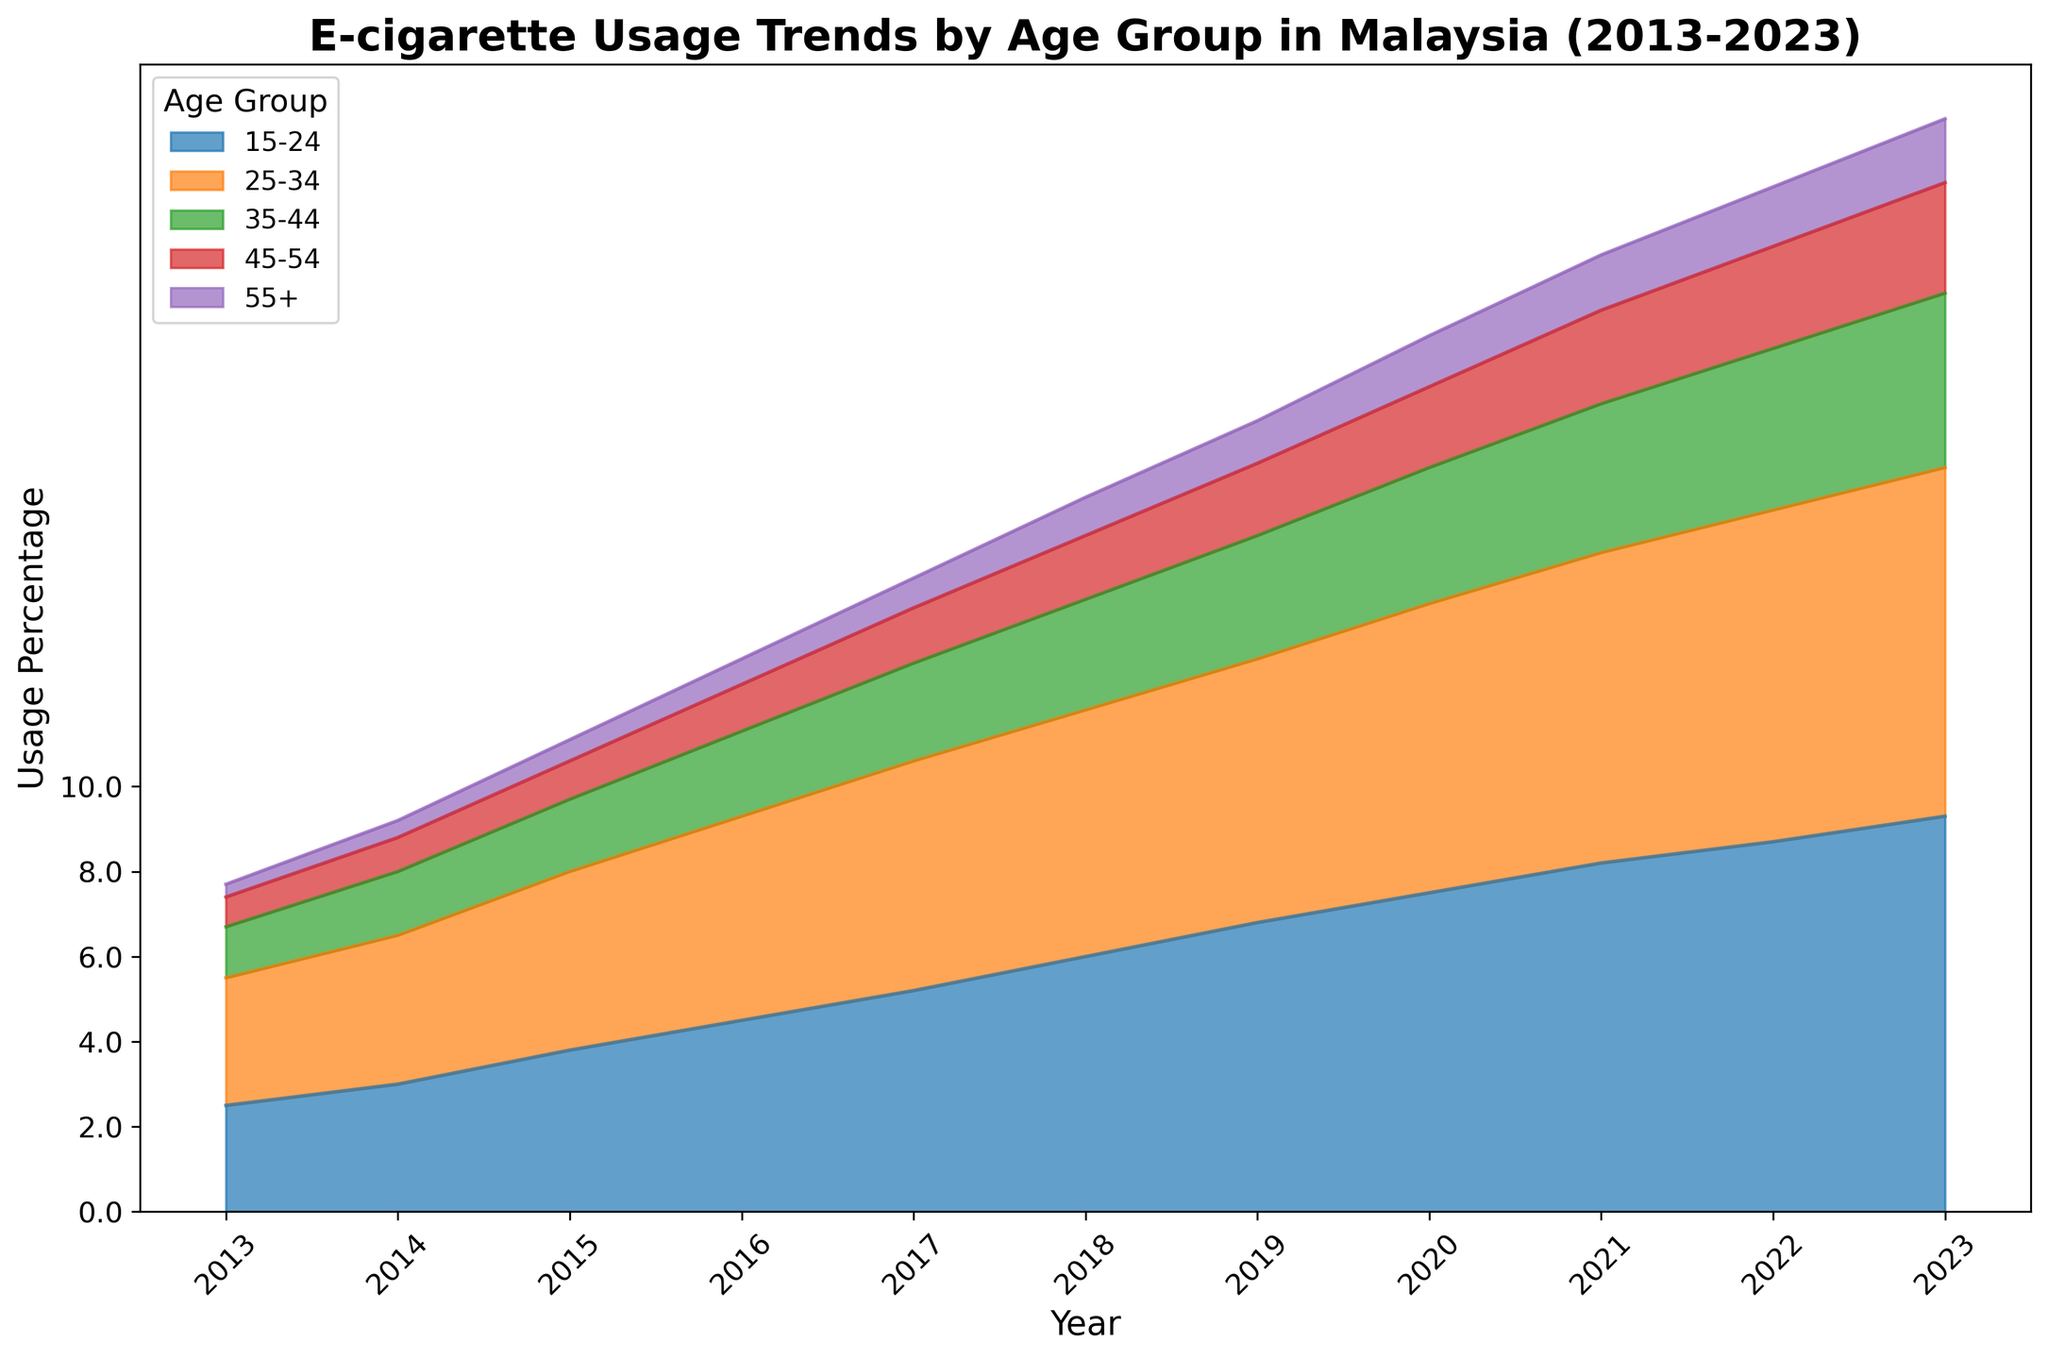What age group shows the highest e-cigarette usage in 2023? Look for the age group with the largest area towards the top of the plot in the year 2023, which is colored distinctly and has the highest percentage among all groups in that year.
Answer: 15-24 How did the e-cigarette usage percentage for the 25-34 age group change from 2013 to 2023? Identify the values for the 25-34 age group at the starting point (2013) and the ending point (2023). Then, subtract the 2013 value from the 2023 value to get the change.
Answer: Increase by 5.2% Which two age groups had an increase in their e-cigarette usage every year from 2013 to 2023? Observe the trend lines for each age group across the years. Look for continuous upward trends without any decline years.
Answer: 15-24 and 25-34 In which year did the total e-cigarette usage percentage across all age groups first exceed 10%? Sum the usage percentages for each age group for every year sequentially until the total exceeds 10%.
Answer: 2015 What was the range of e-cigarette usage percentages for the 35-44 age group from 2013 to 2023? Identify the minimum and maximum usage percentages for the 35-44 age group within the given years and subtract the minimum value from the maximum value to find the range.
Answer: 4.1% - 1.2% = 2.9% Between 2018 and 2023, which age group showed the smallest increase in e-cigarette usage? Calculate the difference in usage percentages for each age group from 2018 to 2023 and identify the group with the smallest increase.
Answer: 55+ Did the 45-54 age group ever have a higher e-cigarette usage percentage than the 35-44 age group? Compare the usage percentages for the 45-54 and 35-44 age groups across each year. Look for any year where the 45-54 percentage is higher than the 35-44 percentage.
Answer: No What is the highest e-cigarette usage percentage observed in the data? Scan through the plot to identify the peak value among all age groups across all years.
Answer: 9.3% For how many years did the 55+ age group have a usage percentage less than 0.5%? Count the number of years where the 55+ age group's usage percentage is below 0.5%.
Answer: 2 years Which year saw the greatest single-year increase in e-cigarette usage percentage for the 15-24 age group? Calculate the year-over-year increase for the 15-24 age group and identify the year with the largest increase.
Answer: 2019 